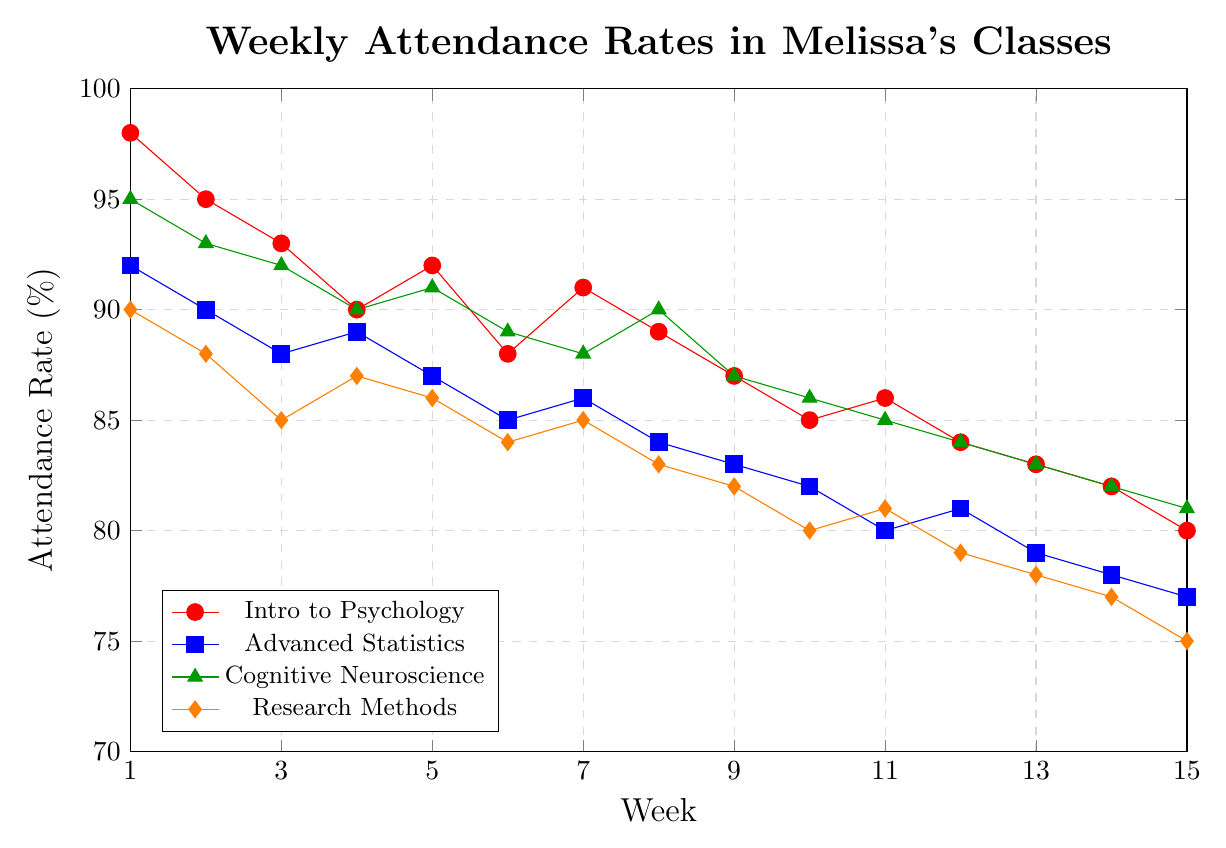Which class has the highest attendance rate in Week 1? Look at the y-values for Week 1 for each class. Intro to Psychology has the highest attendance rate at 98%.
Answer: Intro to Psychology By how much did the attendance rate for Cognitive Neuroscience decrease from Week 1 to Week 15? In Week 1, the attendance rate for Cognitive Neuroscience is 95%. In Week 15, it is 81%. The decrease is 95 - 81 = 14%.
Answer: 14% Which class shows the smallest decline in attendance rate from Week 1 to Week 15? Calculate the difference between Week 1 and Week 15 attendance rates for all classes: 
Intro to Psychology: 98 - 80 = 18 
Advanced Statistics: 92 - 77 = 15 
Cognitive Neuroscience: 95 - 81 = 14 
Research Methods: 90 - 75 = 15 
Cognitive Neuroscience shows the smallest decline with 14%.
Answer: Cognitive Neuroscience What is the average attendance rate for Research Methods in the first 5 weeks? Attendance rates for Research Methods in the first 5 weeks are 90, 88, 85, 87, 86. Sum is 90 + 88 + 85 + 87 + 86 = 436. Average is 436 / 5 = 87.2
Answer: 87.2% Which class has the steepest decline in attendance rate between consecutive weeks? Visually inspect the slopes of the lines between consecutive weeks. Intro to Psychology has the steepest decline between Weeks 1 and 2, from 98 to 95 (a drop of 3%).
Answer: Intro to Psychology (Weeks 1-2) How does the attendance rate for Advanced Statistics in Week 10 compare to that for Intro to Psychology in Week 6? Advanced Statistics in Week 10 is 82%. Intro to Psychology in Week 6 is 88%. Comparatively, Intro to Psychology is higher.
Answer: Intro to Psychology is higher During which week do Advanced Statistics and Research Methods both make the smallest jump or decline? Check the weekly changes for both classes to determine the smallest change. Advanced Statistics has the smallest change between Weeks 4 and 5 (from 89 to 87, a drop of 2%), and Research Methods has the same smallest change between Weeks 4 and 5 (from 87 to 86, a drop of 1%).
Answer: Week 5 At what week do the attendance rates for Cognitive Neuroscience and Advanced Statistics converge? Look for the point where both lines intersect or are closest. This happens in Week 13, where Cognitive Neuroscience is 83% and Advanced Statistics is approximately 79%.
Answer: Week 13 Is there any week where all class attendance rates are above 80%? Check the y-values for all classes across each week. For example, in Week 1, all classes (98%, 92%, 95%, 90%) are above 80%. This only holds for Week 1.
Answer: Week 1 What visual element indicates the highest variability in attendance over the semester? Look for the line with the most fluctuations. "Research Methods" and "Intro to Psychology" show relatively high variability due to the steeper slopes and frequent changes in attendance rates compared to the other classes.
Answer: The frequency of changes in the line slopes 